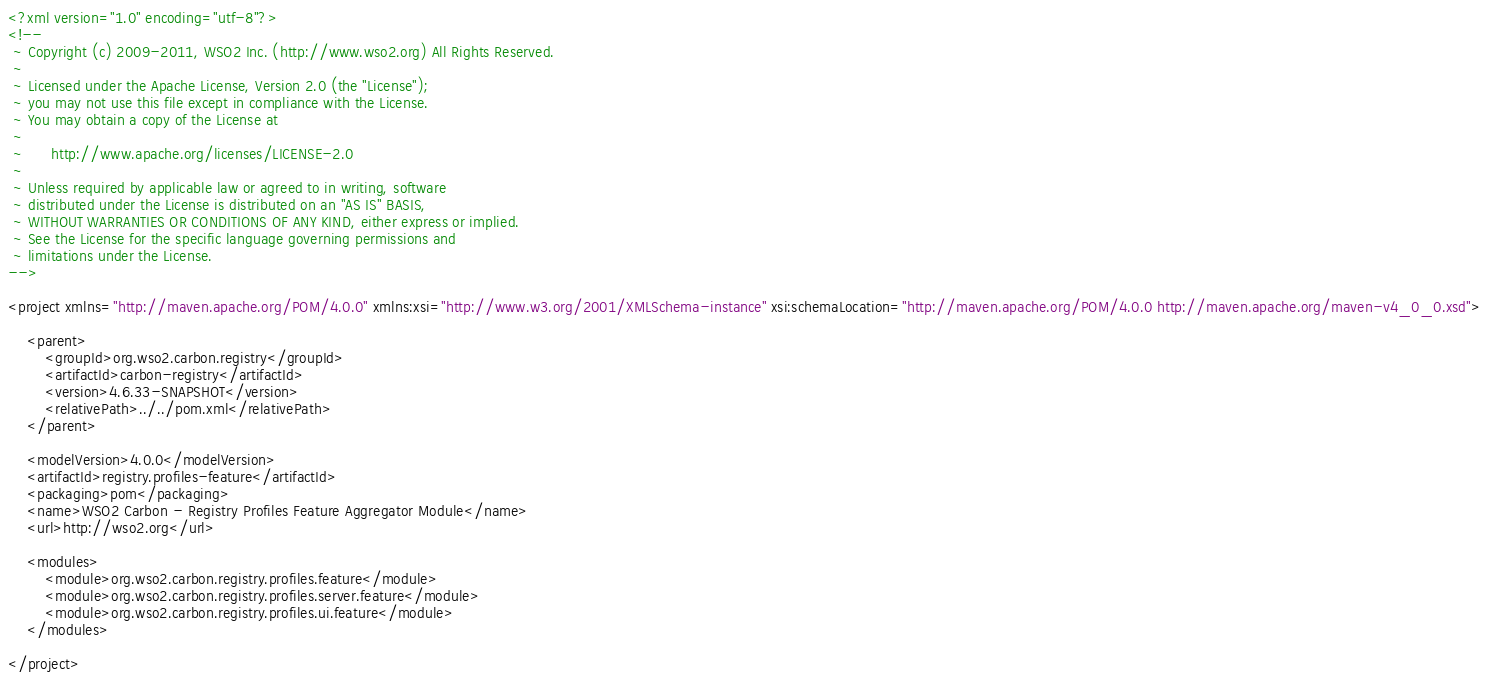Convert code to text. <code><loc_0><loc_0><loc_500><loc_500><_XML_><?xml version="1.0" encoding="utf-8"?>
<!--
 ~ Copyright (c) 2009-2011, WSO2 Inc. (http://www.wso2.org) All Rights Reserved.
 ~
 ~ Licensed under the Apache License, Version 2.0 (the "License");
 ~ you may not use this file except in compliance with the License.
 ~ You may obtain a copy of the License at
 ~
 ~      http://www.apache.org/licenses/LICENSE-2.0
 ~
 ~ Unless required by applicable law or agreed to in writing, software
 ~ distributed under the License is distributed on an "AS IS" BASIS,
 ~ WITHOUT WARRANTIES OR CONDITIONS OF ANY KIND, either express or implied.
 ~ See the License for the specific language governing permissions and
 ~ limitations under the License.
-->

<project xmlns="http://maven.apache.org/POM/4.0.0" xmlns:xsi="http://www.w3.org/2001/XMLSchema-instance" xsi:schemaLocation="http://maven.apache.org/POM/4.0.0 http://maven.apache.org/maven-v4_0_0.xsd">

    <parent>
        <groupId>org.wso2.carbon.registry</groupId>
        <artifactId>carbon-registry</artifactId>
        <version>4.6.33-SNAPSHOT</version>
        <relativePath>../../pom.xml</relativePath>
    </parent>

    <modelVersion>4.0.0</modelVersion>
    <artifactId>registry.profiles-feature</artifactId>
    <packaging>pom</packaging>
    <name>WSO2 Carbon - Registry Profiles Feature Aggregator Module</name>
    <url>http://wso2.org</url>

    <modules>
        <module>org.wso2.carbon.registry.profiles.feature</module>
        <module>org.wso2.carbon.registry.profiles.server.feature</module>
        <module>org.wso2.carbon.registry.profiles.ui.feature</module>
    </modules>

</project>

</code> 